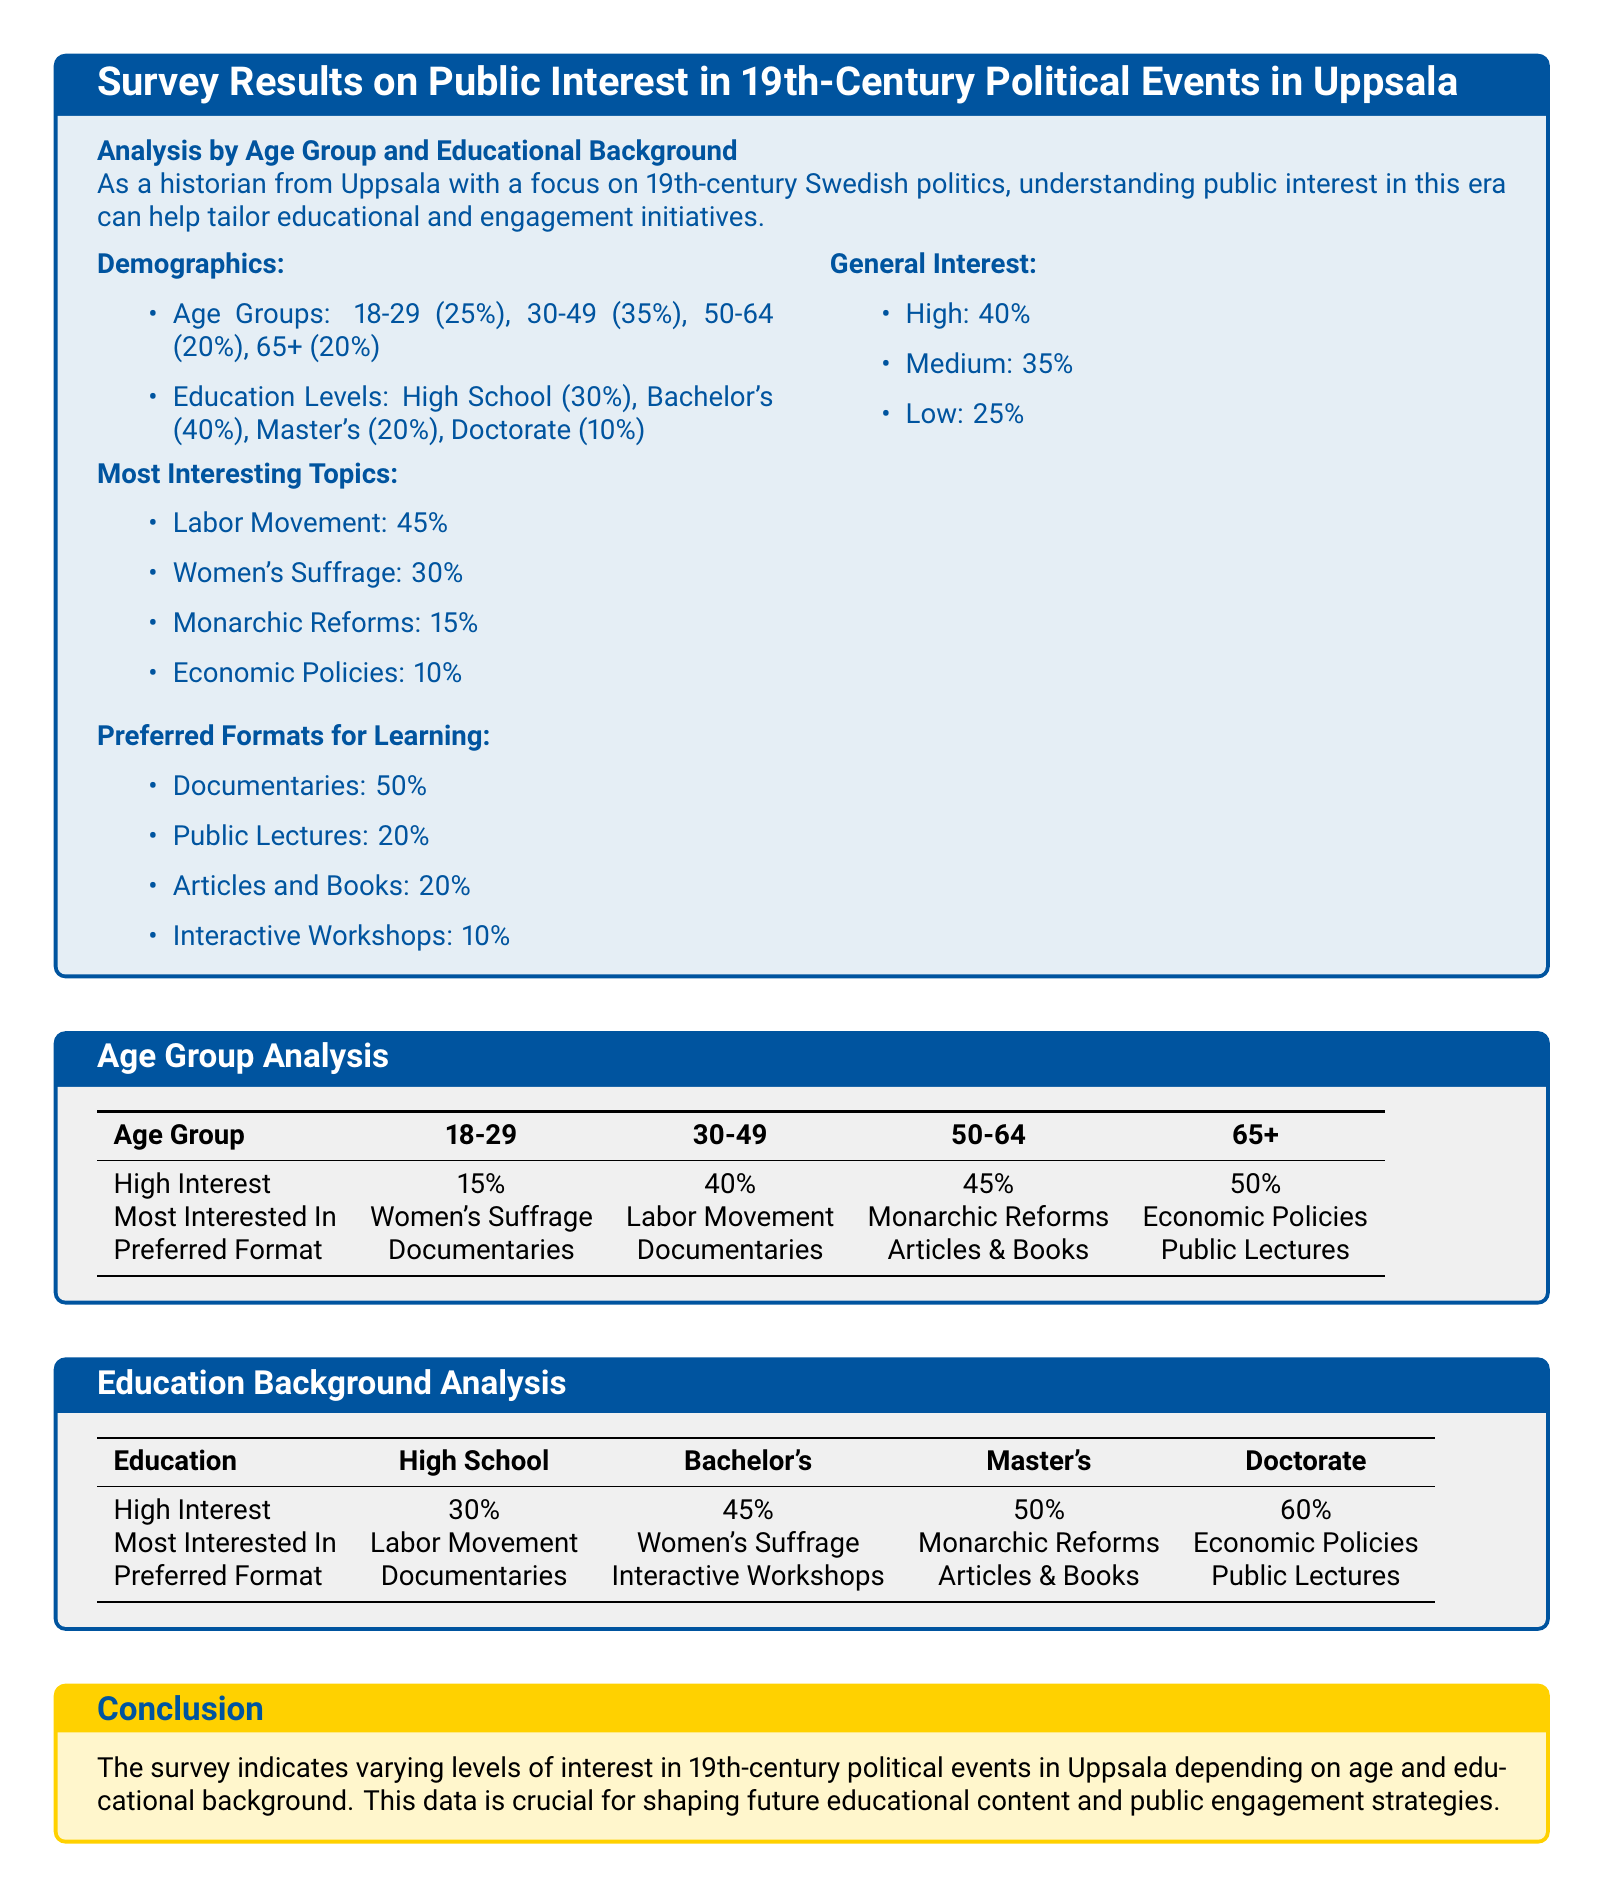What percentage of respondents fall in the age group 30-49? The document states that 35% of respondents belong to the age group 30-49.
Answer: 35% What is the most interesting topic for the majority of respondents? The most interesting topic indicated in the survey is the Labor Movement, which garnered 45% interest.
Answer: Labor Movement What educational background has the highest percentage of high interest in the survey results? The educational background with the highest percentage of high interest is Doctorate at 60%.
Answer: Doctorate What percentage of the 18-29 age group showed high interest? According to the document, 15% of the 18-29 age group have high interest.
Answer: 15% Which preferred format for learning is indicated by those with a Master's degree? The preferred format for learning by respondents with a Master's degree is Articles and Books.
Answer: Articles and Books What percentage of respondents have a high school level of education? The document indicates that 30% of respondents have a high school level of education.
Answer: 30% What preferred format do the 65+ age group members prefer? The preferred format for the 65+ age group, according to the survey results, is Public Lectures.
Answer: Public Lectures How many respondents are mostly interested in Women's Suffrage from the age group 30-49? The document states that the 30-49 age group is mostly interested in Women's Suffrage.
Answer: Women's Suffrage 